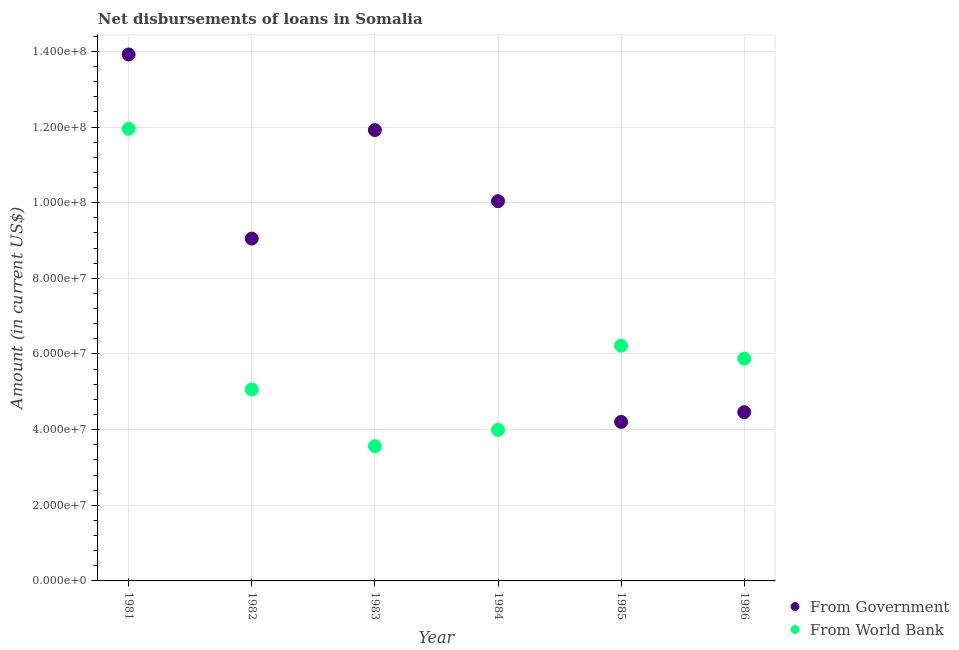How many different coloured dotlines are there?
Provide a succinct answer. 2. What is the net disbursements of loan from world bank in 1986?
Your answer should be compact. 5.88e+07. Across all years, what is the maximum net disbursements of loan from world bank?
Make the answer very short. 1.20e+08. Across all years, what is the minimum net disbursements of loan from world bank?
Your response must be concise. 3.56e+07. In which year was the net disbursements of loan from government maximum?
Provide a short and direct response. 1981. What is the total net disbursements of loan from world bank in the graph?
Give a very brief answer. 3.67e+08. What is the difference between the net disbursements of loan from world bank in 1982 and that in 1984?
Your answer should be compact. 1.07e+07. What is the difference between the net disbursements of loan from world bank in 1986 and the net disbursements of loan from government in 1984?
Provide a succinct answer. -4.16e+07. What is the average net disbursements of loan from world bank per year?
Give a very brief answer. 6.11e+07. In the year 1983, what is the difference between the net disbursements of loan from world bank and net disbursements of loan from government?
Provide a succinct answer. -8.36e+07. What is the ratio of the net disbursements of loan from world bank in 1982 to that in 1986?
Your answer should be very brief. 0.86. Is the net disbursements of loan from government in 1981 less than that in 1983?
Offer a very short reply. No. Is the difference between the net disbursements of loan from government in 1981 and 1982 greater than the difference between the net disbursements of loan from world bank in 1981 and 1982?
Your response must be concise. No. What is the difference between the highest and the second highest net disbursements of loan from government?
Offer a very short reply. 2.00e+07. What is the difference between the highest and the lowest net disbursements of loan from world bank?
Your answer should be compact. 8.39e+07. Is the sum of the net disbursements of loan from world bank in 1984 and 1986 greater than the maximum net disbursements of loan from government across all years?
Offer a terse response. No. How many dotlines are there?
Keep it short and to the point. 2. Are the values on the major ticks of Y-axis written in scientific E-notation?
Provide a succinct answer. Yes. Does the graph contain any zero values?
Your answer should be very brief. No. Does the graph contain grids?
Your response must be concise. Yes. Where does the legend appear in the graph?
Make the answer very short. Bottom right. What is the title of the graph?
Your response must be concise. Net disbursements of loans in Somalia. What is the label or title of the X-axis?
Offer a very short reply. Year. What is the label or title of the Y-axis?
Your answer should be very brief. Amount (in current US$). What is the Amount (in current US$) in From Government in 1981?
Give a very brief answer. 1.39e+08. What is the Amount (in current US$) of From World Bank in 1981?
Offer a terse response. 1.20e+08. What is the Amount (in current US$) of From Government in 1982?
Make the answer very short. 9.05e+07. What is the Amount (in current US$) of From World Bank in 1982?
Your response must be concise. 5.06e+07. What is the Amount (in current US$) of From Government in 1983?
Make the answer very short. 1.19e+08. What is the Amount (in current US$) of From World Bank in 1983?
Keep it short and to the point. 3.56e+07. What is the Amount (in current US$) in From Government in 1984?
Make the answer very short. 1.00e+08. What is the Amount (in current US$) of From World Bank in 1984?
Offer a terse response. 3.99e+07. What is the Amount (in current US$) in From Government in 1985?
Give a very brief answer. 4.20e+07. What is the Amount (in current US$) of From World Bank in 1985?
Ensure brevity in your answer.  6.22e+07. What is the Amount (in current US$) of From Government in 1986?
Provide a short and direct response. 4.46e+07. What is the Amount (in current US$) in From World Bank in 1986?
Provide a succinct answer. 5.88e+07. Across all years, what is the maximum Amount (in current US$) of From Government?
Offer a terse response. 1.39e+08. Across all years, what is the maximum Amount (in current US$) in From World Bank?
Ensure brevity in your answer.  1.20e+08. Across all years, what is the minimum Amount (in current US$) in From Government?
Give a very brief answer. 4.20e+07. Across all years, what is the minimum Amount (in current US$) in From World Bank?
Your response must be concise. 3.56e+07. What is the total Amount (in current US$) in From Government in the graph?
Your answer should be compact. 5.36e+08. What is the total Amount (in current US$) in From World Bank in the graph?
Make the answer very short. 3.67e+08. What is the difference between the Amount (in current US$) of From Government in 1981 and that in 1982?
Provide a succinct answer. 4.87e+07. What is the difference between the Amount (in current US$) in From World Bank in 1981 and that in 1982?
Offer a very short reply. 6.89e+07. What is the difference between the Amount (in current US$) in From Government in 1981 and that in 1983?
Offer a very short reply. 2.00e+07. What is the difference between the Amount (in current US$) in From World Bank in 1981 and that in 1983?
Offer a terse response. 8.39e+07. What is the difference between the Amount (in current US$) of From Government in 1981 and that in 1984?
Keep it short and to the point. 3.88e+07. What is the difference between the Amount (in current US$) of From World Bank in 1981 and that in 1984?
Offer a very short reply. 7.96e+07. What is the difference between the Amount (in current US$) of From Government in 1981 and that in 1985?
Offer a very short reply. 9.72e+07. What is the difference between the Amount (in current US$) of From World Bank in 1981 and that in 1985?
Ensure brevity in your answer.  5.74e+07. What is the difference between the Amount (in current US$) in From Government in 1981 and that in 1986?
Offer a terse response. 9.46e+07. What is the difference between the Amount (in current US$) of From World Bank in 1981 and that in 1986?
Your answer should be compact. 6.08e+07. What is the difference between the Amount (in current US$) of From Government in 1982 and that in 1983?
Keep it short and to the point. -2.87e+07. What is the difference between the Amount (in current US$) of From World Bank in 1982 and that in 1983?
Your answer should be very brief. 1.50e+07. What is the difference between the Amount (in current US$) in From Government in 1982 and that in 1984?
Provide a short and direct response. -9.89e+06. What is the difference between the Amount (in current US$) in From World Bank in 1982 and that in 1984?
Keep it short and to the point. 1.07e+07. What is the difference between the Amount (in current US$) of From Government in 1982 and that in 1985?
Make the answer very short. 4.85e+07. What is the difference between the Amount (in current US$) in From World Bank in 1982 and that in 1985?
Ensure brevity in your answer.  -1.16e+07. What is the difference between the Amount (in current US$) in From Government in 1982 and that in 1986?
Keep it short and to the point. 4.59e+07. What is the difference between the Amount (in current US$) in From World Bank in 1982 and that in 1986?
Your answer should be very brief. -8.16e+06. What is the difference between the Amount (in current US$) of From Government in 1983 and that in 1984?
Ensure brevity in your answer.  1.88e+07. What is the difference between the Amount (in current US$) of From World Bank in 1983 and that in 1984?
Offer a terse response. -4.30e+06. What is the difference between the Amount (in current US$) of From Government in 1983 and that in 1985?
Provide a short and direct response. 7.72e+07. What is the difference between the Amount (in current US$) of From World Bank in 1983 and that in 1985?
Give a very brief answer. -2.66e+07. What is the difference between the Amount (in current US$) of From Government in 1983 and that in 1986?
Provide a short and direct response. 7.46e+07. What is the difference between the Amount (in current US$) of From World Bank in 1983 and that in 1986?
Offer a very short reply. -2.31e+07. What is the difference between the Amount (in current US$) in From Government in 1984 and that in 1985?
Make the answer very short. 5.84e+07. What is the difference between the Amount (in current US$) in From World Bank in 1984 and that in 1985?
Your answer should be compact. -2.23e+07. What is the difference between the Amount (in current US$) in From Government in 1984 and that in 1986?
Provide a succinct answer. 5.58e+07. What is the difference between the Amount (in current US$) of From World Bank in 1984 and that in 1986?
Your answer should be very brief. -1.88e+07. What is the difference between the Amount (in current US$) of From Government in 1985 and that in 1986?
Make the answer very short. -2.58e+06. What is the difference between the Amount (in current US$) in From World Bank in 1985 and that in 1986?
Provide a succinct answer. 3.42e+06. What is the difference between the Amount (in current US$) of From Government in 1981 and the Amount (in current US$) of From World Bank in 1982?
Offer a very short reply. 8.86e+07. What is the difference between the Amount (in current US$) of From Government in 1981 and the Amount (in current US$) of From World Bank in 1983?
Your response must be concise. 1.04e+08. What is the difference between the Amount (in current US$) in From Government in 1981 and the Amount (in current US$) in From World Bank in 1984?
Your answer should be compact. 9.93e+07. What is the difference between the Amount (in current US$) in From Government in 1981 and the Amount (in current US$) in From World Bank in 1985?
Offer a terse response. 7.70e+07. What is the difference between the Amount (in current US$) in From Government in 1981 and the Amount (in current US$) in From World Bank in 1986?
Your answer should be very brief. 8.04e+07. What is the difference between the Amount (in current US$) in From Government in 1982 and the Amount (in current US$) in From World Bank in 1983?
Your response must be concise. 5.49e+07. What is the difference between the Amount (in current US$) in From Government in 1982 and the Amount (in current US$) in From World Bank in 1984?
Your response must be concise. 5.06e+07. What is the difference between the Amount (in current US$) of From Government in 1982 and the Amount (in current US$) of From World Bank in 1985?
Provide a short and direct response. 2.83e+07. What is the difference between the Amount (in current US$) of From Government in 1982 and the Amount (in current US$) of From World Bank in 1986?
Provide a short and direct response. 3.17e+07. What is the difference between the Amount (in current US$) of From Government in 1983 and the Amount (in current US$) of From World Bank in 1984?
Provide a succinct answer. 7.93e+07. What is the difference between the Amount (in current US$) in From Government in 1983 and the Amount (in current US$) in From World Bank in 1985?
Your answer should be very brief. 5.70e+07. What is the difference between the Amount (in current US$) in From Government in 1983 and the Amount (in current US$) in From World Bank in 1986?
Your response must be concise. 6.04e+07. What is the difference between the Amount (in current US$) of From Government in 1984 and the Amount (in current US$) of From World Bank in 1985?
Ensure brevity in your answer.  3.82e+07. What is the difference between the Amount (in current US$) of From Government in 1984 and the Amount (in current US$) of From World Bank in 1986?
Provide a short and direct response. 4.16e+07. What is the difference between the Amount (in current US$) of From Government in 1985 and the Amount (in current US$) of From World Bank in 1986?
Your answer should be compact. -1.67e+07. What is the average Amount (in current US$) of From Government per year?
Your answer should be compact. 8.93e+07. What is the average Amount (in current US$) in From World Bank per year?
Offer a very short reply. 6.11e+07. In the year 1981, what is the difference between the Amount (in current US$) of From Government and Amount (in current US$) of From World Bank?
Keep it short and to the point. 1.96e+07. In the year 1982, what is the difference between the Amount (in current US$) of From Government and Amount (in current US$) of From World Bank?
Your answer should be very brief. 3.99e+07. In the year 1983, what is the difference between the Amount (in current US$) of From Government and Amount (in current US$) of From World Bank?
Provide a short and direct response. 8.36e+07. In the year 1984, what is the difference between the Amount (in current US$) of From Government and Amount (in current US$) of From World Bank?
Provide a succinct answer. 6.05e+07. In the year 1985, what is the difference between the Amount (in current US$) in From Government and Amount (in current US$) in From World Bank?
Provide a short and direct response. -2.01e+07. In the year 1986, what is the difference between the Amount (in current US$) of From Government and Amount (in current US$) of From World Bank?
Your response must be concise. -1.41e+07. What is the ratio of the Amount (in current US$) in From Government in 1981 to that in 1982?
Offer a terse response. 1.54. What is the ratio of the Amount (in current US$) of From World Bank in 1981 to that in 1982?
Offer a very short reply. 2.36. What is the ratio of the Amount (in current US$) of From Government in 1981 to that in 1983?
Offer a terse response. 1.17. What is the ratio of the Amount (in current US$) in From World Bank in 1981 to that in 1983?
Provide a succinct answer. 3.36. What is the ratio of the Amount (in current US$) in From Government in 1981 to that in 1984?
Provide a short and direct response. 1.39. What is the ratio of the Amount (in current US$) of From World Bank in 1981 to that in 1984?
Give a very brief answer. 2.99. What is the ratio of the Amount (in current US$) in From Government in 1981 to that in 1985?
Provide a short and direct response. 3.31. What is the ratio of the Amount (in current US$) of From World Bank in 1981 to that in 1985?
Give a very brief answer. 1.92. What is the ratio of the Amount (in current US$) in From Government in 1981 to that in 1986?
Give a very brief answer. 3.12. What is the ratio of the Amount (in current US$) of From World Bank in 1981 to that in 1986?
Your answer should be compact. 2.03. What is the ratio of the Amount (in current US$) in From Government in 1982 to that in 1983?
Keep it short and to the point. 0.76. What is the ratio of the Amount (in current US$) of From World Bank in 1982 to that in 1983?
Keep it short and to the point. 1.42. What is the ratio of the Amount (in current US$) of From Government in 1982 to that in 1984?
Give a very brief answer. 0.9. What is the ratio of the Amount (in current US$) in From World Bank in 1982 to that in 1984?
Ensure brevity in your answer.  1.27. What is the ratio of the Amount (in current US$) of From Government in 1982 to that in 1985?
Give a very brief answer. 2.15. What is the ratio of the Amount (in current US$) in From World Bank in 1982 to that in 1985?
Ensure brevity in your answer.  0.81. What is the ratio of the Amount (in current US$) in From Government in 1982 to that in 1986?
Offer a very short reply. 2.03. What is the ratio of the Amount (in current US$) in From World Bank in 1982 to that in 1986?
Provide a short and direct response. 0.86. What is the ratio of the Amount (in current US$) in From Government in 1983 to that in 1984?
Ensure brevity in your answer.  1.19. What is the ratio of the Amount (in current US$) of From World Bank in 1983 to that in 1984?
Make the answer very short. 0.89. What is the ratio of the Amount (in current US$) of From Government in 1983 to that in 1985?
Provide a short and direct response. 2.84. What is the ratio of the Amount (in current US$) in From World Bank in 1983 to that in 1985?
Offer a very short reply. 0.57. What is the ratio of the Amount (in current US$) of From Government in 1983 to that in 1986?
Offer a terse response. 2.67. What is the ratio of the Amount (in current US$) of From World Bank in 1983 to that in 1986?
Provide a short and direct response. 0.61. What is the ratio of the Amount (in current US$) of From Government in 1984 to that in 1985?
Give a very brief answer. 2.39. What is the ratio of the Amount (in current US$) in From World Bank in 1984 to that in 1985?
Provide a succinct answer. 0.64. What is the ratio of the Amount (in current US$) of From Government in 1984 to that in 1986?
Keep it short and to the point. 2.25. What is the ratio of the Amount (in current US$) of From World Bank in 1984 to that in 1986?
Offer a terse response. 0.68. What is the ratio of the Amount (in current US$) of From Government in 1985 to that in 1986?
Provide a short and direct response. 0.94. What is the ratio of the Amount (in current US$) of From World Bank in 1985 to that in 1986?
Ensure brevity in your answer.  1.06. What is the difference between the highest and the second highest Amount (in current US$) in From Government?
Make the answer very short. 2.00e+07. What is the difference between the highest and the second highest Amount (in current US$) of From World Bank?
Offer a very short reply. 5.74e+07. What is the difference between the highest and the lowest Amount (in current US$) in From Government?
Your answer should be very brief. 9.72e+07. What is the difference between the highest and the lowest Amount (in current US$) in From World Bank?
Offer a terse response. 8.39e+07. 